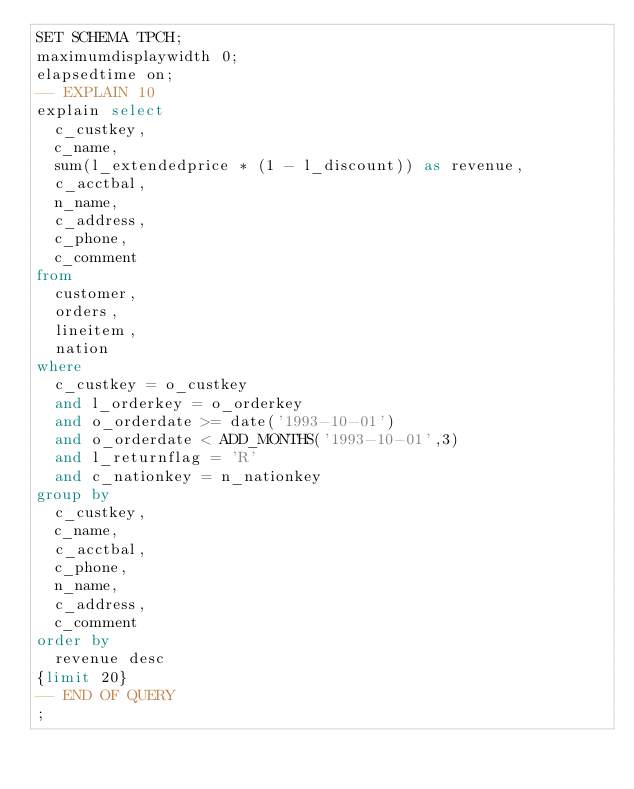Convert code to text. <code><loc_0><loc_0><loc_500><loc_500><_SQL_>SET SCHEMA TPCH;
maximumdisplaywidth 0;
elapsedtime on;
-- EXPLAIN 10
explain select
	c_custkey,
	c_name,
	sum(l_extendedprice * (1 - l_discount)) as revenue,
	c_acctbal,
	n_name,
	c_address,
	c_phone,
	c_comment
from
	customer,
	orders,
	lineitem,
	nation
where
	c_custkey = o_custkey
	and l_orderkey = o_orderkey
	and o_orderdate >= date('1993-10-01')
	and o_orderdate < ADD_MONTHS('1993-10-01',3) 
	and l_returnflag = 'R'
	and c_nationkey = n_nationkey
group by
	c_custkey,
	c_name,
	c_acctbal,
	c_phone,
	n_name,
	c_address,
	c_comment
order by
	revenue desc
{limit 20}
-- END OF QUERY
;
</code> 